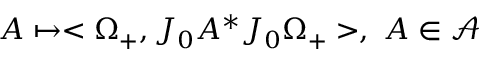<formula> <loc_0><loc_0><loc_500><loc_500>A \mapsto < \Omega _ { + } , J _ { 0 } A ^ { \ast } J _ { 0 } \Omega _ { + } > , \, A \in \mathcal { A }</formula> 